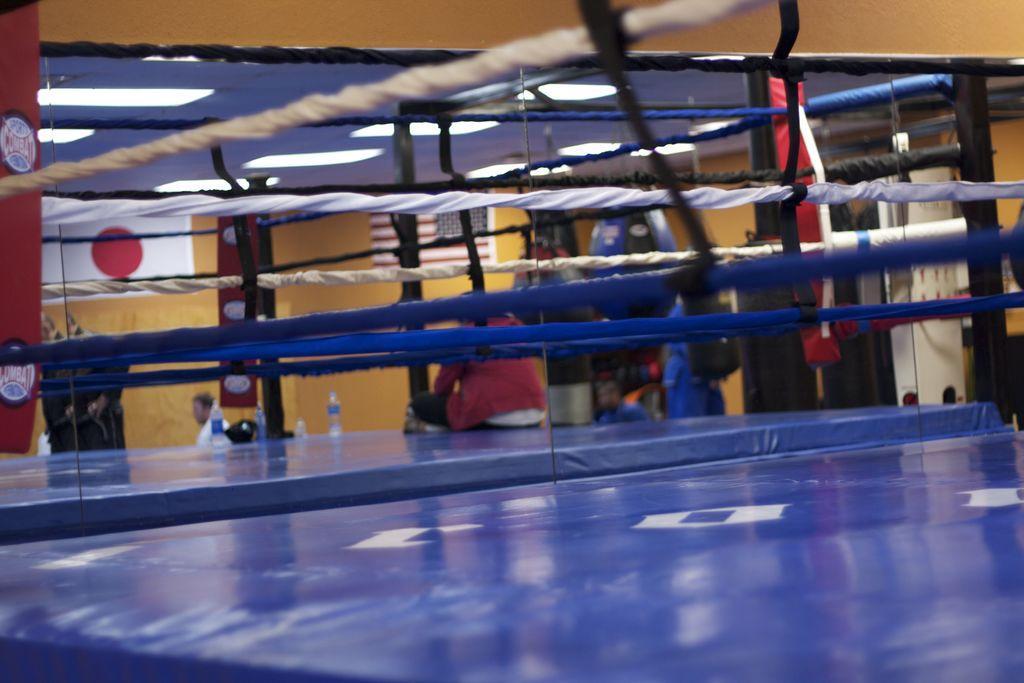Could you give a brief overview of what you see in this image? In this picture there is boxing ring in the center of the image. 